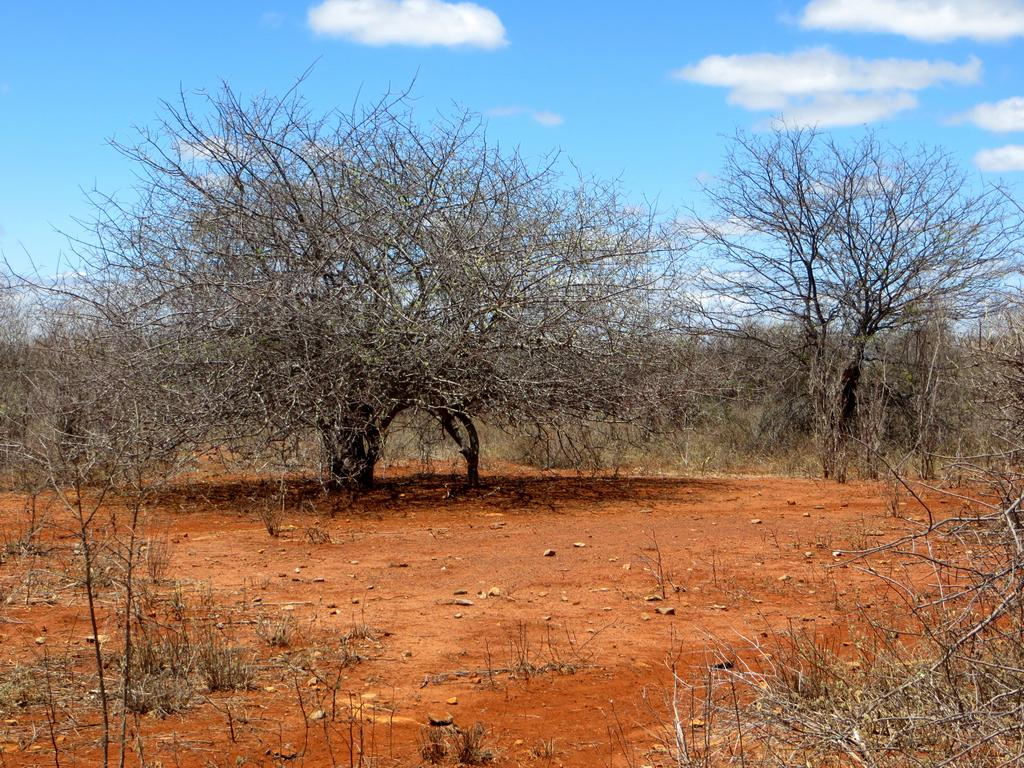What is visible in the background of the image? The sky is visible in the image. What can be seen in the sky in the image? Clouds are present in the image. What type of vegetation is visible in the image? Trees are present in the image. What is the condition of the ground in the image? Dry grass is visible in the image. What type of kettle is being used to fight the clouds in the image? There is no kettle or fighting depicted in the image; it features the sky, clouds, trees, and dry grass. Can you see any wires hanging from the trees in the image? There is no mention of wires or any hanging objects in the trees in the image. 